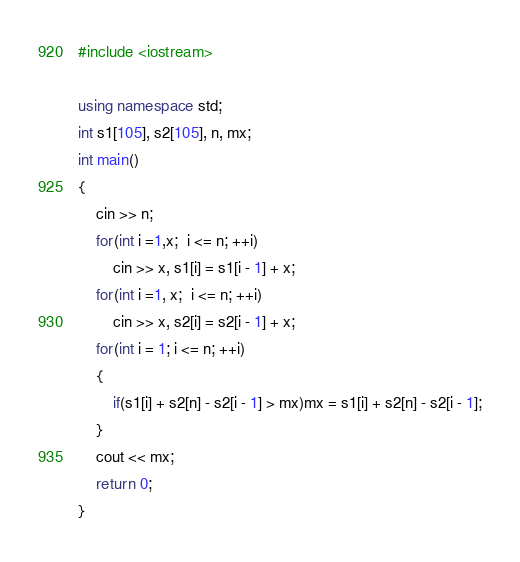<code> <loc_0><loc_0><loc_500><loc_500><_C++_>#include <iostream>

using namespace std;
int s1[105], s2[105], n, mx;
int main()
{
    cin >> n;
    for(int i =1,x;  i <= n; ++i)
        cin >> x, s1[i] = s1[i - 1] + x;
    for(int i =1, x;  i <= n; ++i)
        cin >> x, s2[i] = s2[i - 1] + x;
    for(int i = 1; i <= n; ++i)
    {
        if(s1[i] + s2[n] - s2[i - 1] > mx)mx = s1[i] + s2[n] - s2[i - 1];
    }
    cout << mx;
    return 0;
}
</code> 